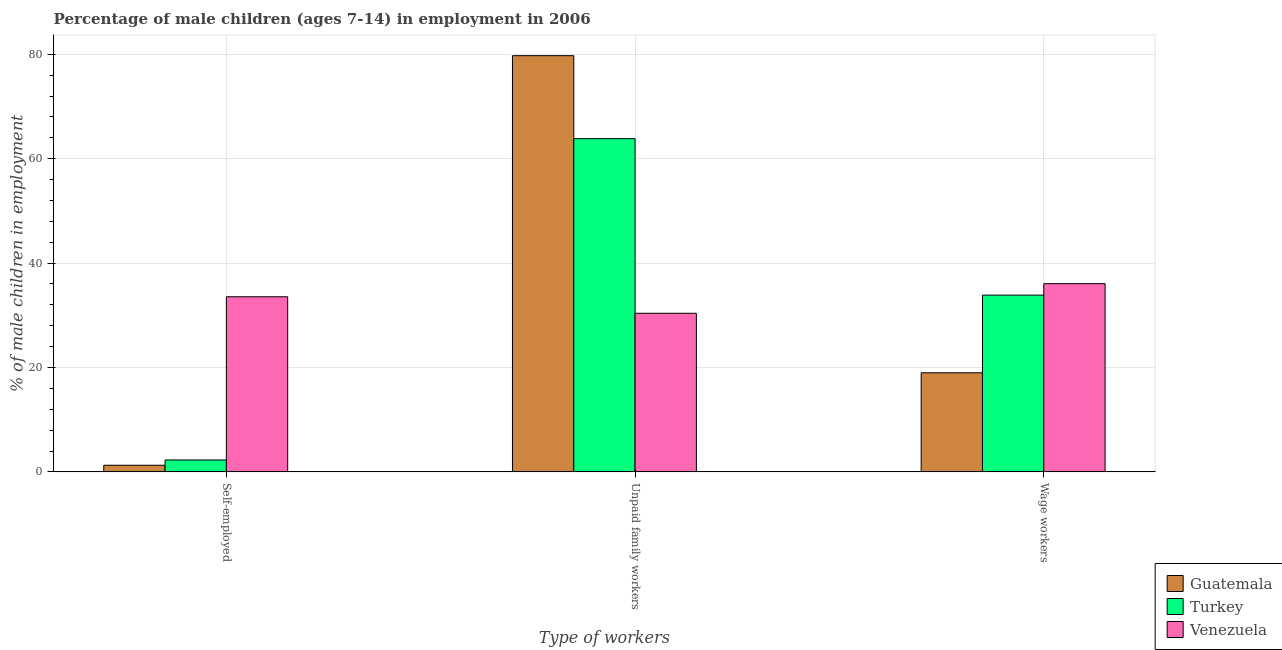How many different coloured bars are there?
Provide a short and direct response. 3. Are the number of bars per tick equal to the number of legend labels?
Provide a short and direct response. Yes. Are the number of bars on each tick of the X-axis equal?
Offer a terse response. Yes. How many bars are there on the 3rd tick from the right?
Ensure brevity in your answer.  3. What is the label of the 1st group of bars from the left?
Offer a terse response. Self-employed. What is the percentage of children employed as unpaid family workers in Venezuela?
Offer a very short reply. 30.39. Across all countries, what is the maximum percentage of self employed children?
Provide a short and direct response. 33.55. Across all countries, what is the minimum percentage of children employed as wage workers?
Your answer should be very brief. 18.99. In which country was the percentage of children employed as wage workers maximum?
Your answer should be compact. Venezuela. In which country was the percentage of children employed as unpaid family workers minimum?
Offer a very short reply. Venezuela. What is the total percentage of self employed children in the graph?
Provide a short and direct response. 37.12. What is the difference between the percentage of self employed children in Venezuela and that in Turkey?
Offer a very short reply. 31.26. What is the difference between the percentage of children employed as wage workers in Turkey and the percentage of self employed children in Guatemala?
Provide a short and direct response. 32.59. What is the average percentage of children employed as unpaid family workers per country?
Provide a short and direct response. 57.99. What is the difference between the percentage of children employed as wage workers and percentage of self employed children in Venezuela?
Keep it short and to the point. 2.51. In how many countries, is the percentage of children employed as wage workers greater than 28 %?
Make the answer very short. 2. What is the ratio of the percentage of self employed children in Turkey to that in Guatemala?
Your response must be concise. 1.79. Is the percentage of children employed as unpaid family workers in Turkey less than that in Venezuela?
Your answer should be compact. No. Is the difference between the percentage of children employed as unpaid family workers in Guatemala and Venezuela greater than the difference between the percentage of self employed children in Guatemala and Venezuela?
Your answer should be very brief. Yes. What is the difference between the highest and the second highest percentage of children employed as unpaid family workers?
Provide a succinct answer. 15.89. What is the difference between the highest and the lowest percentage of children employed as unpaid family workers?
Provide a succinct answer. 49.34. What does the 3rd bar from the left in Wage workers represents?
Your answer should be very brief. Venezuela. What does the 2nd bar from the right in Self-employed represents?
Your response must be concise. Turkey. Is it the case that in every country, the sum of the percentage of self employed children and percentage of children employed as unpaid family workers is greater than the percentage of children employed as wage workers?
Your response must be concise. Yes. Are all the bars in the graph horizontal?
Offer a terse response. No. Does the graph contain any zero values?
Provide a succinct answer. No. Where does the legend appear in the graph?
Your answer should be very brief. Bottom right. How many legend labels are there?
Offer a very short reply. 3. What is the title of the graph?
Provide a short and direct response. Percentage of male children (ages 7-14) in employment in 2006. Does "Belgium" appear as one of the legend labels in the graph?
Your answer should be compact. No. What is the label or title of the X-axis?
Give a very brief answer. Type of workers. What is the label or title of the Y-axis?
Provide a succinct answer. % of male children in employment. What is the % of male children in employment of Guatemala in Self-employed?
Keep it short and to the point. 1.28. What is the % of male children in employment in Turkey in Self-employed?
Give a very brief answer. 2.29. What is the % of male children in employment in Venezuela in Self-employed?
Your response must be concise. 33.55. What is the % of male children in employment in Guatemala in Unpaid family workers?
Your response must be concise. 79.73. What is the % of male children in employment in Turkey in Unpaid family workers?
Your answer should be compact. 63.84. What is the % of male children in employment of Venezuela in Unpaid family workers?
Offer a terse response. 30.39. What is the % of male children in employment of Guatemala in Wage workers?
Provide a short and direct response. 18.99. What is the % of male children in employment of Turkey in Wage workers?
Your response must be concise. 33.87. What is the % of male children in employment in Venezuela in Wage workers?
Offer a very short reply. 36.06. Across all Type of workers, what is the maximum % of male children in employment of Guatemala?
Your answer should be compact. 79.73. Across all Type of workers, what is the maximum % of male children in employment of Turkey?
Keep it short and to the point. 63.84. Across all Type of workers, what is the maximum % of male children in employment in Venezuela?
Your response must be concise. 36.06. Across all Type of workers, what is the minimum % of male children in employment in Guatemala?
Your answer should be compact. 1.28. Across all Type of workers, what is the minimum % of male children in employment of Turkey?
Give a very brief answer. 2.29. Across all Type of workers, what is the minimum % of male children in employment in Venezuela?
Make the answer very short. 30.39. What is the difference between the % of male children in employment of Guatemala in Self-employed and that in Unpaid family workers?
Give a very brief answer. -78.45. What is the difference between the % of male children in employment of Turkey in Self-employed and that in Unpaid family workers?
Provide a succinct answer. -61.55. What is the difference between the % of male children in employment in Venezuela in Self-employed and that in Unpaid family workers?
Provide a succinct answer. 3.16. What is the difference between the % of male children in employment in Guatemala in Self-employed and that in Wage workers?
Keep it short and to the point. -17.71. What is the difference between the % of male children in employment of Turkey in Self-employed and that in Wage workers?
Make the answer very short. -31.58. What is the difference between the % of male children in employment of Venezuela in Self-employed and that in Wage workers?
Your response must be concise. -2.51. What is the difference between the % of male children in employment of Guatemala in Unpaid family workers and that in Wage workers?
Offer a terse response. 60.74. What is the difference between the % of male children in employment of Turkey in Unpaid family workers and that in Wage workers?
Offer a terse response. 29.97. What is the difference between the % of male children in employment in Venezuela in Unpaid family workers and that in Wage workers?
Keep it short and to the point. -5.67. What is the difference between the % of male children in employment of Guatemala in Self-employed and the % of male children in employment of Turkey in Unpaid family workers?
Keep it short and to the point. -62.56. What is the difference between the % of male children in employment in Guatemala in Self-employed and the % of male children in employment in Venezuela in Unpaid family workers?
Your response must be concise. -29.11. What is the difference between the % of male children in employment in Turkey in Self-employed and the % of male children in employment in Venezuela in Unpaid family workers?
Keep it short and to the point. -28.1. What is the difference between the % of male children in employment of Guatemala in Self-employed and the % of male children in employment of Turkey in Wage workers?
Ensure brevity in your answer.  -32.59. What is the difference between the % of male children in employment of Guatemala in Self-employed and the % of male children in employment of Venezuela in Wage workers?
Your response must be concise. -34.78. What is the difference between the % of male children in employment of Turkey in Self-employed and the % of male children in employment of Venezuela in Wage workers?
Offer a terse response. -33.77. What is the difference between the % of male children in employment of Guatemala in Unpaid family workers and the % of male children in employment of Turkey in Wage workers?
Offer a terse response. 45.86. What is the difference between the % of male children in employment in Guatemala in Unpaid family workers and the % of male children in employment in Venezuela in Wage workers?
Provide a succinct answer. 43.67. What is the difference between the % of male children in employment of Turkey in Unpaid family workers and the % of male children in employment of Venezuela in Wage workers?
Your answer should be very brief. 27.78. What is the average % of male children in employment of Guatemala per Type of workers?
Your answer should be compact. 33.33. What is the average % of male children in employment of Turkey per Type of workers?
Offer a very short reply. 33.33. What is the average % of male children in employment in Venezuela per Type of workers?
Give a very brief answer. 33.33. What is the difference between the % of male children in employment of Guatemala and % of male children in employment of Turkey in Self-employed?
Your answer should be compact. -1.01. What is the difference between the % of male children in employment in Guatemala and % of male children in employment in Venezuela in Self-employed?
Give a very brief answer. -32.27. What is the difference between the % of male children in employment in Turkey and % of male children in employment in Venezuela in Self-employed?
Give a very brief answer. -31.26. What is the difference between the % of male children in employment of Guatemala and % of male children in employment of Turkey in Unpaid family workers?
Provide a succinct answer. 15.89. What is the difference between the % of male children in employment of Guatemala and % of male children in employment of Venezuela in Unpaid family workers?
Offer a very short reply. 49.34. What is the difference between the % of male children in employment in Turkey and % of male children in employment in Venezuela in Unpaid family workers?
Your answer should be compact. 33.45. What is the difference between the % of male children in employment of Guatemala and % of male children in employment of Turkey in Wage workers?
Your response must be concise. -14.88. What is the difference between the % of male children in employment in Guatemala and % of male children in employment in Venezuela in Wage workers?
Offer a terse response. -17.07. What is the difference between the % of male children in employment in Turkey and % of male children in employment in Venezuela in Wage workers?
Give a very brief answer. -2.19. What is the ratio of the % of male children in employment of Guatemala in Self-employed to that in Unpaid family workers?
Offer a terse response. 0.02. What is the ratio of the % of male children in employment in Turkey in Self-employed to that in Unpaid family workers?
Offer a very short reply. 0.04. What is the ratio of the % of male children in employment in Venezuela in Self-employed to that in Unpaid family workers?
Provide a succinct answer. 1.1. What is the ratio of the % of male children in employment in Guatemala in Self-employed to that in Wage workers?
Your response must be concise. 0.07. What is the ratio of the % of male children in employment in Turkey in Self-employed to that in Wage workers?
Offer a very short reply. 0.07. What is the ratio of the % of male children in employment of Venezuela in Self-employed to that in Wage workers?
Your answer should be compact. 0.93. What is the ratio of the % of male children in employment of Guatemala in Unpaid family workers to that in Wage workers?
Offer a very short reply. 4.2. What is the ratio of the % of male children in employment in Turkey in Unpaid family workers to that in Wage workers?
Give a very brief answer. 1.88. What is the ratio of the % of male children in employment of Venezuela in Unpaid family workers to that in Wage workers?
Your answer should be compact. 0.84. What is the difference between the highest and the second highest % of male children in employment in Guatemala?
Your response must be concise. 60.74. What is the difference between the highest and the second highest % of male children in employment of Turkey?
Ensure brevity in your answer.  29.97. What is the difference between the highest and the second highest % of male children in employment in Venezuela?
Offer a very short reply. 2.51. What is the difference between the highest and the lowest % of male children in employment of Guatemala?
Your response must be concise. 78.45. What is the difference between the highest and the lowest % of male children in employment in Turkey?
Your answer should be compact. 61.55. What is the difference between the highest and the lowest % of male children in employment in Venezuela?
Ensure brevity in your answer.  5.67. 